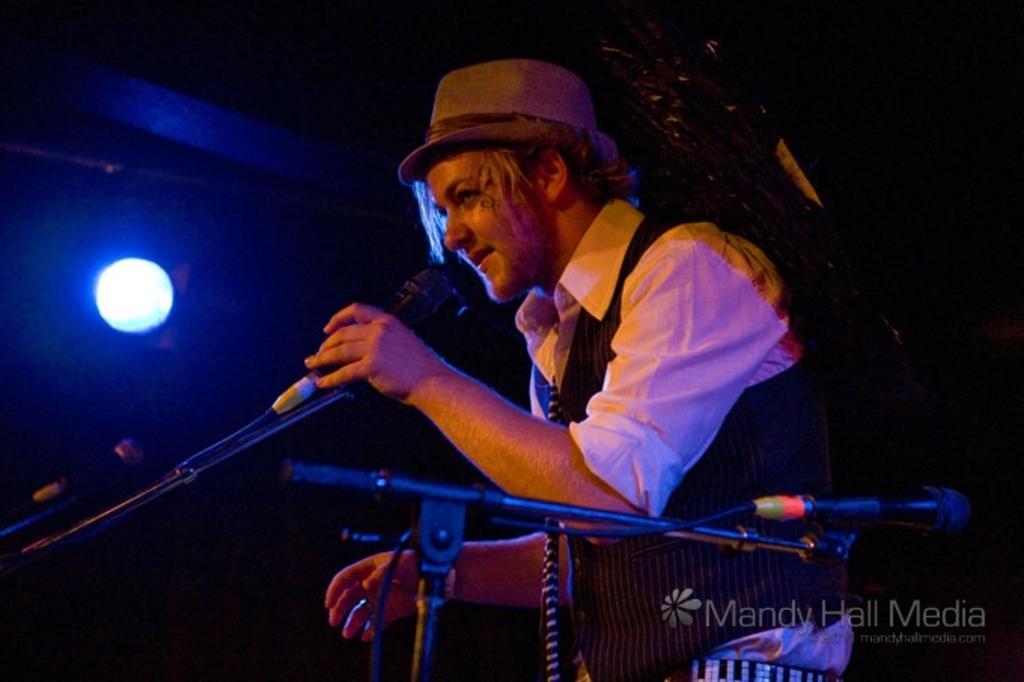In one or two sentences, can you explain what this image depicts? On the bottom right, there is a watermark. On the right side, there is a person in a white color shirt, holding a mic which is attached to a stand. In the background, there is a light. And the background is dark in color. 